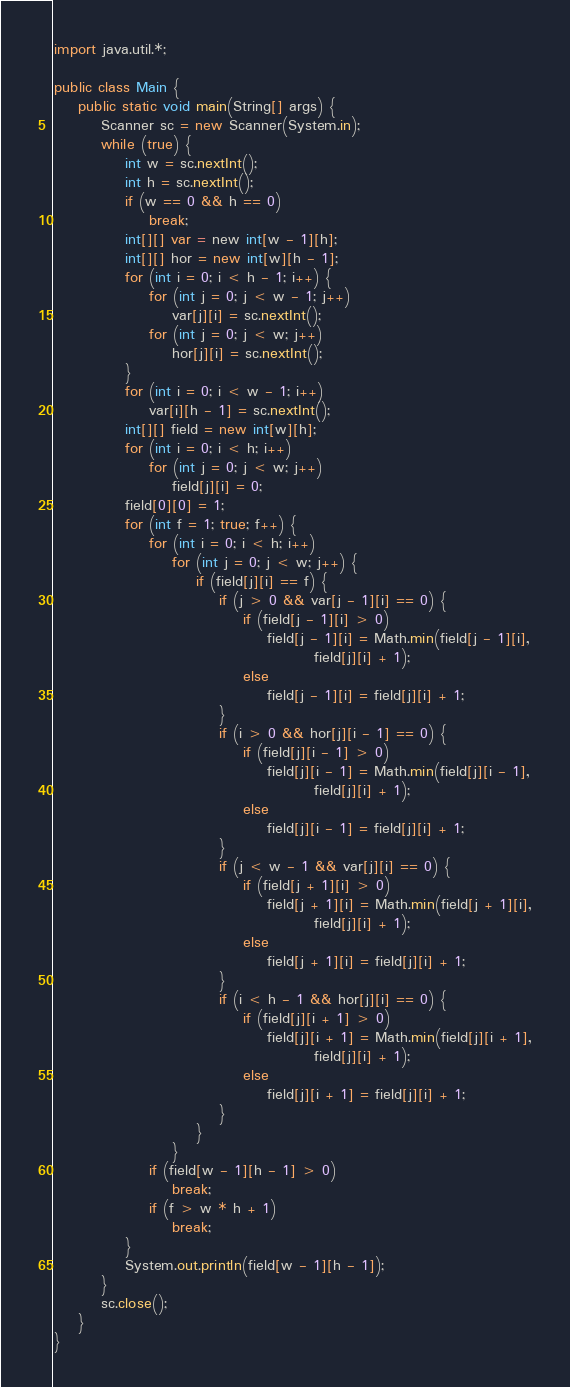Convert code to text. <code><loc_0><loc_0><loc_500><loc_500><_Java_>import java.util.*;

public class Main {
	public static void main(String[] args) {
		Scanner sc = new Scanner(System.in);
		while (true) {
			int w = sc.nextInt();
			int h = sc.nextInt();
			if (w == 0 && h == 0)
				break;
			int[][] var = new int[w - 1][h];
			int[][] hor = new int[w][h - 1];
			for (int i = 0; i < h - 1; i++) {
				for (int j = 0; j < w - 1; j++)
					var[j][i] = sc.nextInt();
				for (int j = 0; j < w; j++)
					hor[j][i] = sc.nextInt();
			}
			for (int i = 0; i < w - 1; i++)
				var[i][h - 1] = sc.nextInt();
			int[][] field = new int[w][h];
			for (int i = 0; i < h; i++)
				for (int j = 0; j < w; j++)
					field[j][i] = 0;
			field[0][0] = 1;
			for (int f = 1; true; f++) {
				for (int i = 0; i < h; i++)
					for (int j = 0; j < w; j++) {
						if (field[j][i] == f) {
							if (j > 0 && var[j - 1][i] == 0) {
								if (field[j - 1][i] > 0)
									field[j - 1][i] = Math.min(field[j - 1][i],
											field[j][i] + 1);
								else
									field[j - 1][i] = field[j][i] + 1;
							}
							if (i > 0 && hor[j][i - 1] == 0) {
								if (field[j][i - 1] > 0)
									field[j][i - 1] = Math.min(field[j][i - 1],
											field[j][i] + 1);
								else
									field[j][i - 1] = field[j][i] + 1;
							}
							if (j < w - 1 && var[j][i] == 0) {
								if (field[j + 1][i] > 0)
									field[j + 1][i] = Math.min(field[j + 1][i],
											field[j][i] + 1);
								else
									field[j + 1][i] = field[j][i] + 1;
							}
							if (i < h - 1 && hor[j][i] == 0) {
								if (field[j][i + 1] > 0)
									field[j][i + 1] = Math.min(field[j][i + 1],
											field[j][i] + 1);
								else
									field[j][i + 1] = field[j][i] + 1;
							}
						}
					}
				if (field[w - 1][h - 1] > 0)
					break;
				if (f > w * h + 1)
					break;
			}
			System.out.println(field[w - 1][h - 1]);
		}
		sc.close();
	}
}</code> 